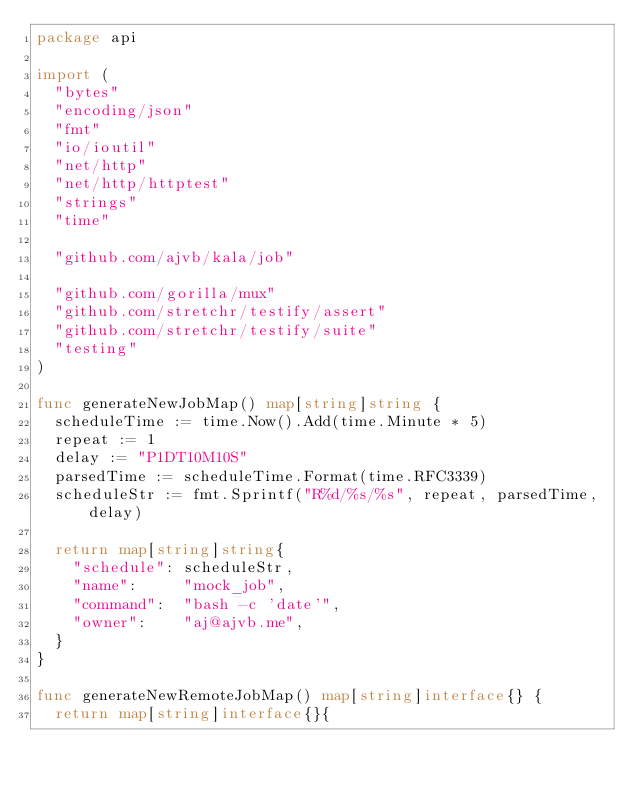<code> <loc_0><loc_0><loc_500><loc_500><_Go_>package api

import (
	"bytes"
	"encoding/json"
	"fmt"
	"io/ioutil"
	"net/http"
	"net/http/httptest"
	"strings"
	"time"

	"github.com/ajvb/kala/job"

	"github.com/gorilla/mux"
	"github.com/stretchr/testify/assert"
	"github.com/stretchr/testify/suite"
	"testing"
)

func generateNewJobMap() map[string]string {
	scheduleTime := time.Now().Add(time.Minute * 5)
	repeat := 1
	delay := "P1DT10M10S"
	parsedTime := scheduleTime.Format(time.RFC3339)
	scheduleStr := fmt.Sprintf("R%d/%s/%s", repeat, parsedTime, delay)

	return map[string]string{
		"schedule": scheduleStr,
		"name":     "mock_job",
		"command":  "bash -c 'date'",
		"owner":    "aj@ajvb.me",
	}
}

func generateNewRemoteJobMap() map[string]interface{} {
	return map[string]interface{}{</code> 